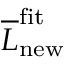Convert formula to latex. <formula><loc_0><loc_0><loc_500><loc_500>\overline { L } _ { n e w } ^ { f i t }</formula> 